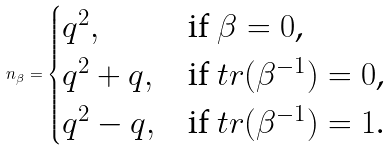Convert formula to latex. <formula><loc_0><loc_0><loc_500><loc_500>n _ { \beta } = \begin{cases} q ^ { 2 } , & \text {if $\beta=0$,} \\ q ^ { 2 } + q , & \text {if $tr(\beta^{-1})=0$,} \\ q ^ { 2 } - q , & \text {if $tr(\beta^{-1})=1$.} \end{cases}</formula> 